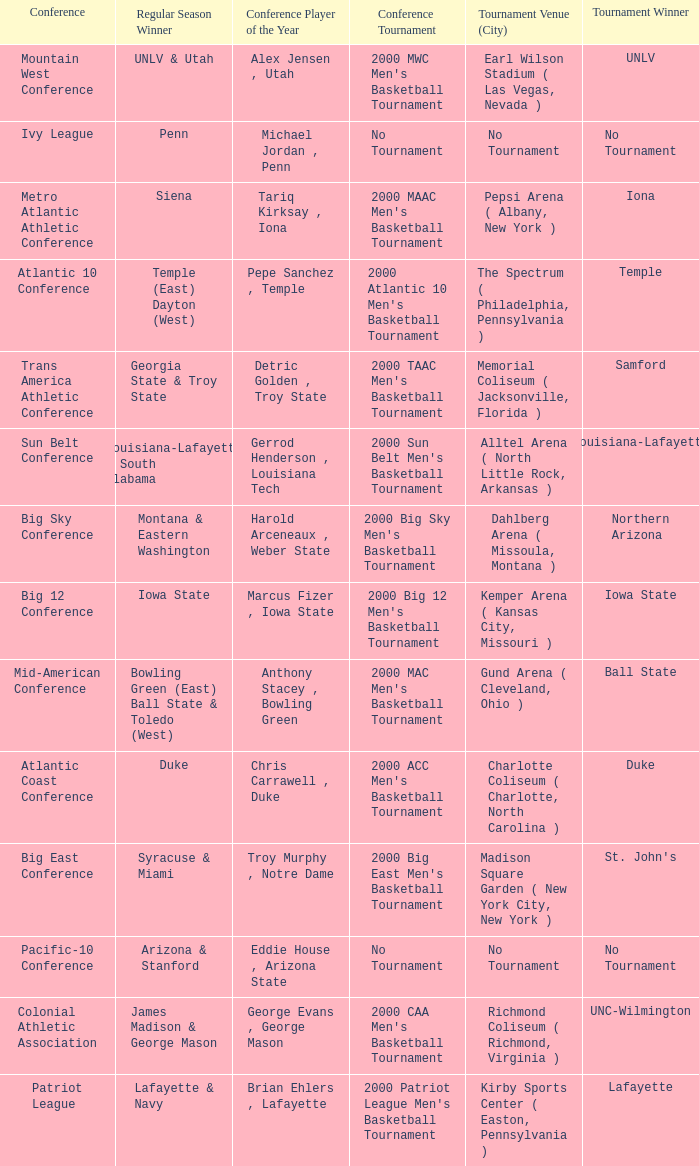What is the venue and city where the 2000 MWC Men's Basketball Tournament? Earl Wilson Stadium ( Las Vegas, Nevada ). 